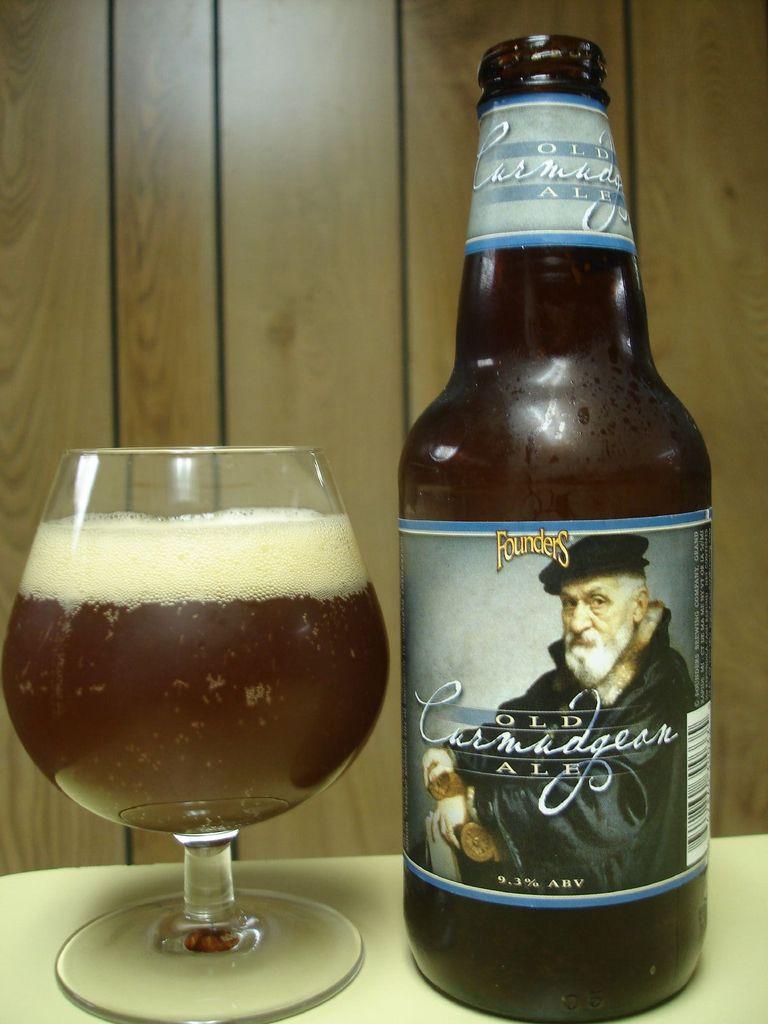Describe this image in one or two sentences. In this picture there is a beer bottle and a beer glass kept on the table. There is a wooden wall in the background. 